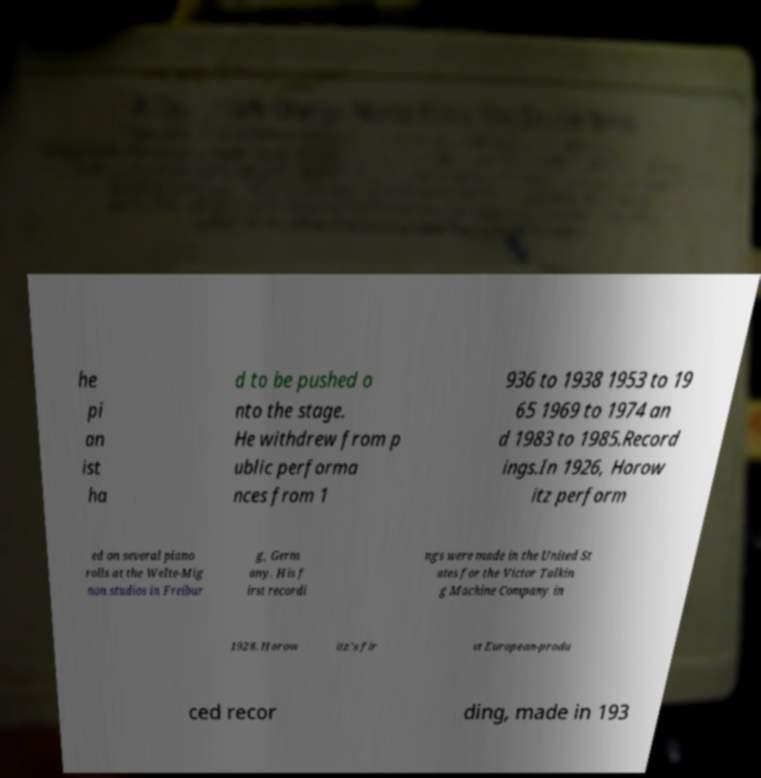Please read and relay the text visible in this image. What does it say? he pi an ist ha d to be pushed o nto the stage. He withdrew from p ublic performa nces from 1 936 to 1938 1953 to 19 65 1969 to 1974 an d 1983 to 1985.Record ings.In 1926, Horow itz perform ed on several piano rolls at the Welte-Mig non studios in Freibur g, Germ any. His f irst recordi ngs were made in the United St ates for the Victor Talkin g Machine Company in 1928. Horow itz's fir st European-produ ced recor ding, made in 193 